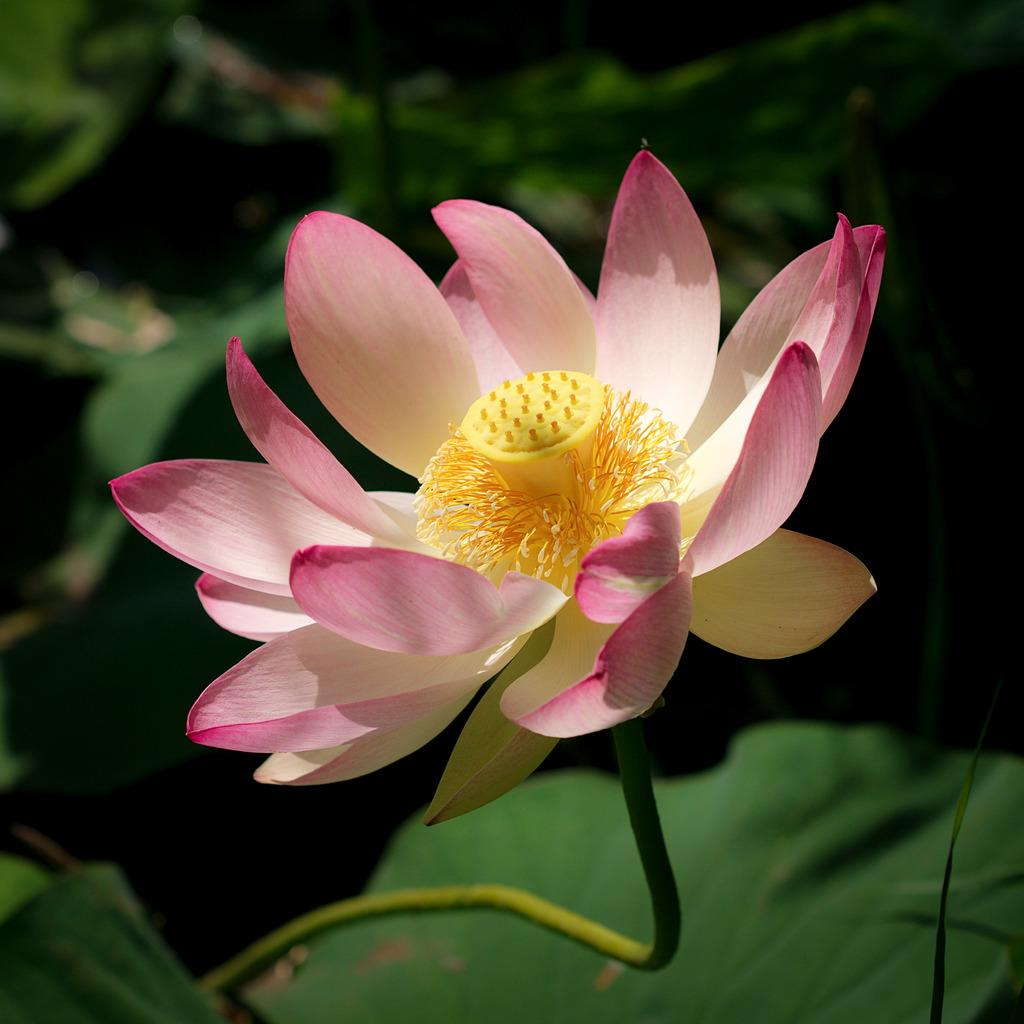What type of flower can be seen on a plant in the image? There is a pink flower on a plant in the image. Can you describe the background of the image? There are other plants visible in the background of the image. How many babies are being carried by the thread in the image? There are no babies or threads present in the image. 